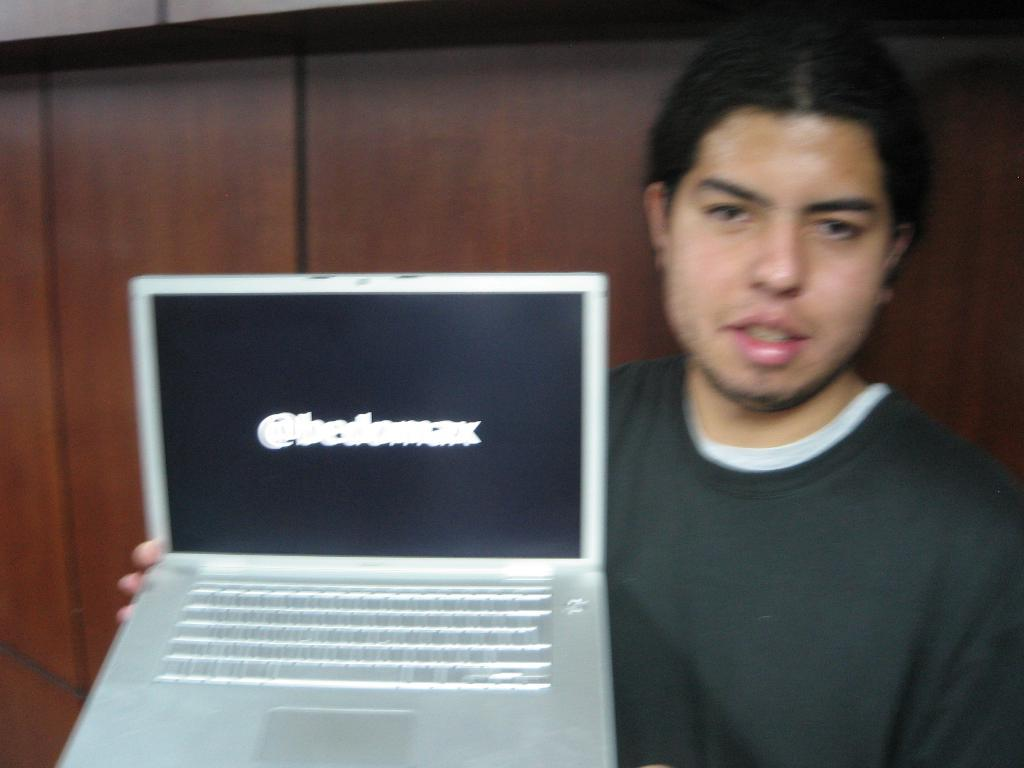What is the main subject of the image? There is a person in the image. What is the person holding in the image? The person is holding a laptop. What can be seen in the background of the image? There is a wooden wall in the background of the image. What type of pot is visible on the person's head in the image? There is no pot visible on the person's head in the image. Can you tell me the credit score of the person in the image? There is no information about the person's credit score in the image. 